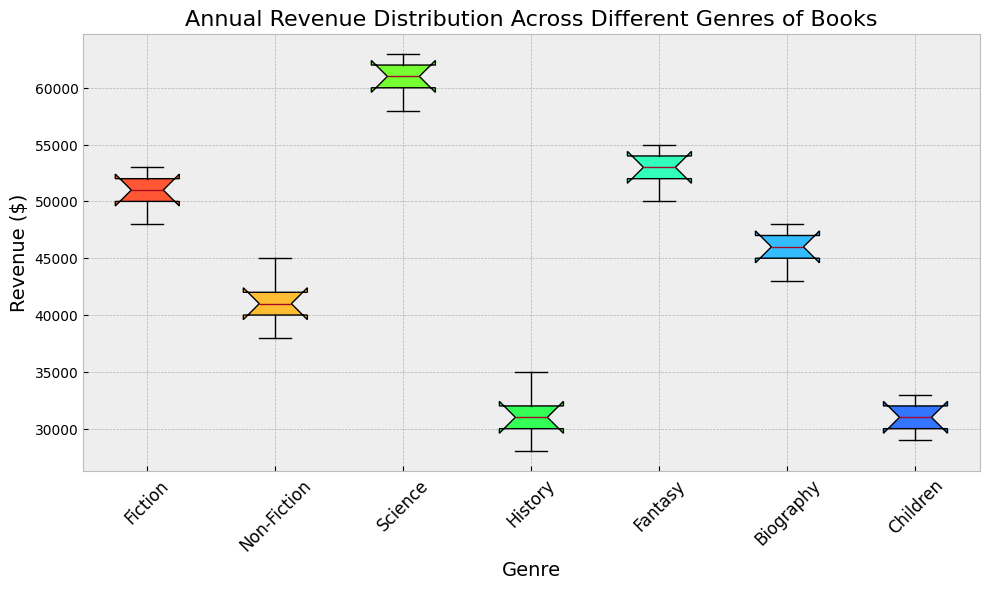Which genre has the highest median annual revenue? Looking at the box plot, the median is indicated by the horizontal line within each box. Among all the genres, Science has the highest median annual revenue.
Answer: Science Which genre has the lowest median annual revenue? The median is indicated by the horizontal line within each box. Among all the genres, History has the lowest median annual revenue.
Answer: History What is the interquartile range (IQR) for the Fiction genre? The IQR is the difference between the upper (Q3) and lower (Q1) quartiles, which are the top and bottom edges of the box. For Fiction, Q1 is approximately 50000 and Q3 is approximately 52000. So, IQR = Q3 - Q1 = 52000 - 50000 = 2000.
Answer: 2000 Which genres have a similar range of annual revenue? The range is the difference between the maximum and minimum values, shown by the lines extending from the top and bottom of the boxes. Both Non-Fiction and Biography have a range close to 10000, showing similar revenue variability.
Answer: Non-Fiction, Biography Which genre’s revenue distribution has the least variability? The width of the box indicates variability. The narrowest box, indicating the least variability in revenue distribution, belongs to Children.
Answer: Children What's the median annual revenue for the Fantasy genre? The median is indicated by the horizontal line within the Fantasy box. It is approximately 53000.
Answer: 53000 Which genre has the largest range of annual revenue? The range is determined by the distance between the top and bottom whiskers. Science has the largest range with values approximately from 58000 to 63000.
Answer: Science How does the revenue distribution for Biography compare to Fiction? By comparing the boxes, Biography's revenue distribution is slightly lower and has a similar variability range, but Fiction's median is higher than Biography's.
Answer: Fiction’s median is higher, similar variability What is the rough median revenue for Children genre? The median is the line within the box, approximately halfway up. For Children, it’s around 31000.
Answer: 31000 Which genres have outliers in their revenue distribution? Outliers are points that fall outside of the whiskers in a box plot. In this data, no genre shows points as significant outliers.
Answer: None 